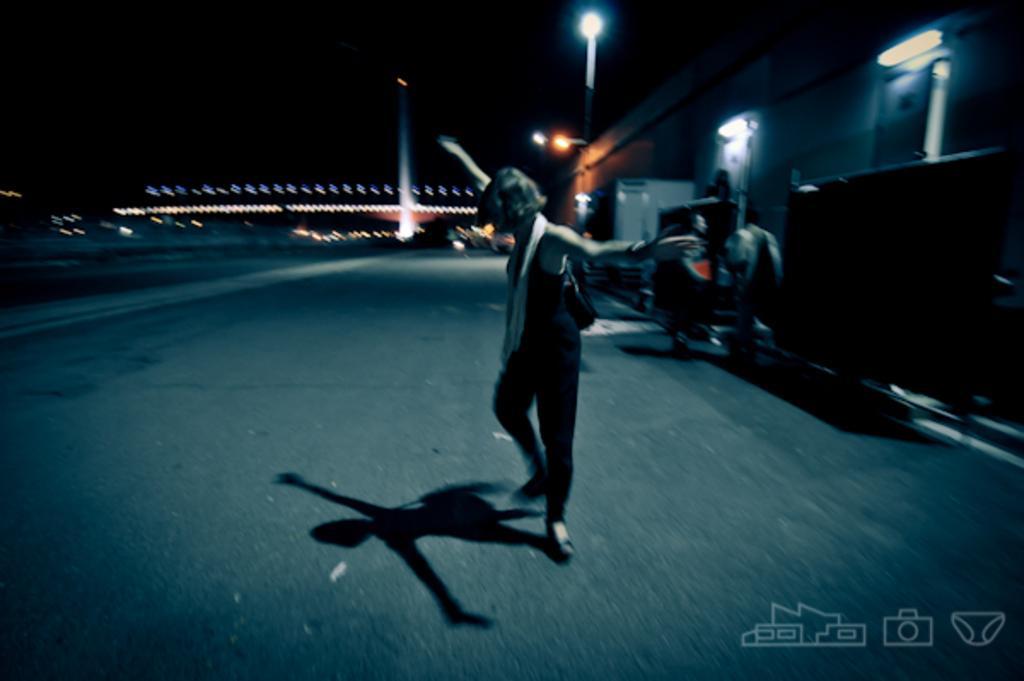In one or two sentences, can you explain what this image depicts? A person is dancing on the road. Background there are lights poles, buildings, people and vehicle. Right side bottom of the image there are logos. 